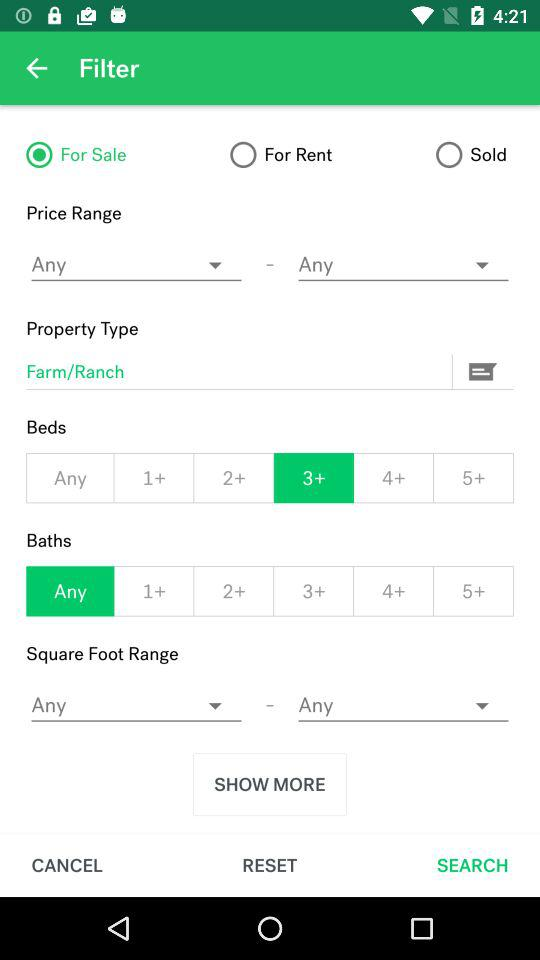Is "For Sale" option selected or not? "For Sale" option is selected. 